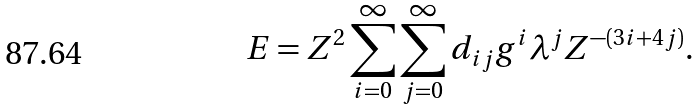Convert formula to latex. <formula><loc_0><loc_0><loc_500><loc_500>E = Z ^ { 2 } \sum _ { i = 0 } ^ { \infty } \sum _ { j = 0 } ^ { \infty } d _ { i j } g ^ { i } \lambda ^ { j } Z ^ { - ( 3 i + 4 j ) } .</formula> 